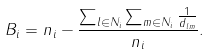<formula> <loc_0><loc_0><loc_500><loc_500>B _ { i } = n _ { i } - \frac { \sum _ { l \in N _ { i } } \sum _ { m \in N _ { i } } \frac { 1 } { d _ { l m } } } { n _ { i } } .</formula> 